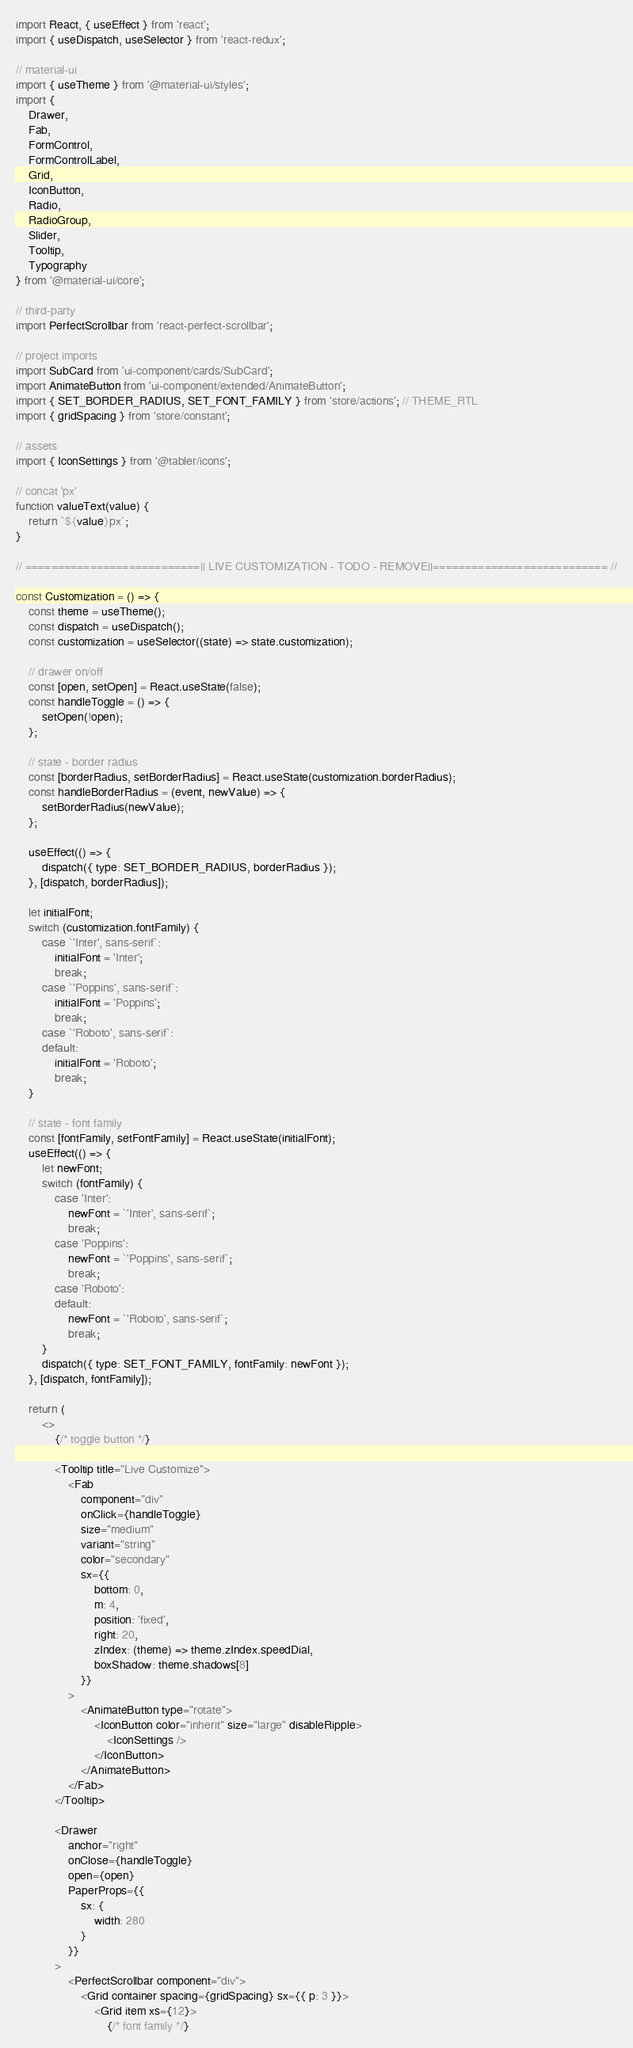<code> <loc_0><loc_0><loc_500><loc_500><_JavaScript_>import React, { useEffect } from 'react';
import { useDispatch, useSelector } from 'react-redux';

// material-ui
import { useTheme } from '@material-ui/styles';
import {
    Drawer,
    Fab,
    FormControl,
    FormControlLabel,
    Grid,
    IconButton,
    Radio,
    RadioGroup,
    Slider,
    Tooltip,
    Typography
} from '@material-ui/core';

// third-party
import PerfectScrollbar from 'react-perfect-scrollbar';

// project imports
import SubCard from 'ui-component/cards/SubCard';
import AnimateButton from 'ui-component/extended/AnimateButton';
import { SET_BORDER_RADIUS, SET_FONT_FAMILY } from 'store/actions'; // THEME_RTL
import { gridSpacing } from 'store/constant';

// assets
import { IconSettings } from '@tabler/icons';

// concat 'px'
function valueText(value) {
    return `${value}px`;
}

// ===========================|| LIVE CUSTOMIZATION - TODO - REMOVE||=========================== //

const Customization = () => {
    const theme = useTheme();
    const dispatch = useDispatch();
    const customization = useSelector((state) => state.customization);

    // drawer on/off
    const [open, setOpen] = React.useState(false);
    const handleToggle = () => {
        setOpen(!open);
    };

    // state - border radius
    const [borderRadius, setBorderRadius] = React.useState(customization.borderRadius);
    const handleBorderRadius = (event, newValue) => {
        setBorderRadius(newValue);
    };

    useEffect(() => {
        dispatch({ type: SET_BORDER_RADIUS, borderRadius });
    }, [dispatch, borderRadius]);

    let initialFont;
    switch (customization.fontFamily) {
        case `'Inter', sans-serif`:
            initialFont = 'Inter';
            break;
        case `'Poppins', sans-serif`:
            initialFont = 'Poppins';
            break;
        case `'Roboto', sans-serif`:
        default:
            initialFont = 'Roboto';
            break;
    }

    // state - font family
    const [fontFamily, setFontFamily] = React.useState(initialFont);
    useEffect(() => {
        let newFont;
        switch (fontFamily) {
            case 'Inter':
                newFont = `'Inter', sans-serif`;
                break;
            case 'Poppins':
                newFont = `'Poppins', sans-serif`;
                break;
            case 'Roboto':
            default:
                newFont = `'Roboto', sans-serif`;
                break;
        }
        dispatch({ type: SET_FONT_FAMILY, fontFamily: newFont });
    }, [dispatch, fontFamily]);

    return (
        <>
            {/* toggle button */}

            <Tooltip title="Live Customize">
                <Fab
                    component="div"
                    onClick={handleToggle}
                    size="medium"
                    variant="string"
                    color="secondary"
                    sx={{
                        bottom: 0,
                        m: 4,
                        position: 'fixed',
                        right: 20,
                        zIndex: (theme) => theme.zIndex.speedDial,
                        boxShadow: theme.shadows[8]
                    }}
                >
                    <AnimateButton type="rotate">
                        <IconButton color="inherit" size="large" disableRipple>
                            <IconSettings />
                        </IconButton>
                    </AnimateButton>
                </Fab>
            </Tooltip>

            <Drawer
                anchor="right"
                onClose={handleToggle}
                open={open}
                PaperProps={{
                    sx: {
                        width: 280
                    }
                }}
            >
                <PerfectScrollbar component="div">
                    <Grid container spacing={gridSpacing} sx={{ p: 3 }}>
                        <Grid item xs={12}>
                            {/* font family */}</code> 